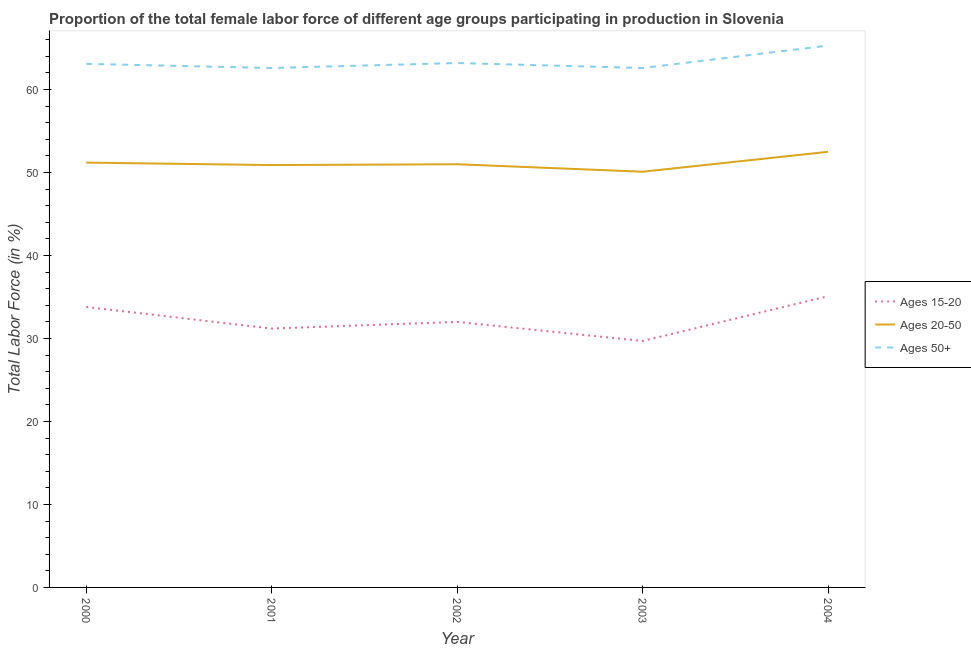What is the percentage of female labor force above age 50 in 2004?
Make the answer very short. 65.3. Across all years, what is the maximum percentage of female labor force above age 50?
Give a very brief answer. 65.3. Across all years, what is the minimum percentage of female labor force above age 50?
Provide a succinct answer. 62.6. In which year was the percentage of female labor force above age 50 minimum?
Your answer should be compact. 2001. What is the total percentage of female labor force within the age group 20-50 in the graph?
Ensure brevity in your answer.  255.7. What is the difference between the percentage of female labor force above age 50 in 2002 and that in 2004?
Your answer should be very brief. -2.1. What is the difference between the percentage of female labor force above age 50 in 2000 and the percentage of female labor force within the age group 20-50 in 2003?
Provide a succinct answer. 13. What is the average percentage of female labor force within the age group 15-20 per year?
Your answer should be compact. 32.36. In the year 2002, what is the difference between the percentage of female labor force above age 50 and percentage of female labor force within the age group 20-50?
Keep it short and to the point. 12.2. What is the ratio of the percentage of female labor force within the age group 20-50 in 2000 to that in 2002?
Give a very brief answer. 1. Is the percentage of female labor force above age 50 in 2000 less than that in 2004?
Offer a terse response. Yes. What is the difference between the highest and the second highest percentage of female labor force within the age group 20-50?
Make the answer very short. 1.3. What is the difference between the highest and the lowest percentage of female labor force within the age group 20-50?
Provide a succinct answer. 2.4. In how many years, is the percentage of female labor force above age 50 greater than the average percentage of female labor force above age 50 taken over all years?
Give a very brief answer. 1. Is the sum of the percentage of female labor force above age 50 in 2002 and 2004 greater than the maximum percentage of female labor force within the age group 15-20 across all years?
Offer a very short reply. Yes. Does the percentage of female labor force within the age group 20-50 monotonically increase over the years?
Keep it short and to the point. No. Is the percentage of female labor force within the age group 15-20 strictly less than the percentage of female labor force within the age group 20-50 over the years?
Keep it short and to the point. Yes. How many years are there in the graph?
Ensure brevity in your answer.  5. Does the graph contain grids?
Offer a terse response. No. Where does the legend appear in the graph?
Your answer should be very brief. Center right. How many legend labels are there?
Keep it short and to the point. 3. How are the legend labels stacked?
Your response must be concise. Vertical. What is the title of the graph?
Your answer should be very brief. Proportion of the total female labor force of different age groups participating in production in Slovenia. Does "Agriculture" appear as one of the legend labels in the graph?
Offer a very short reply. No. What is the label or title of the Y-axis?
Offer a terse response. Total Labor Force (in %). What is the Total Labor Force (in %) of Ages 15-20 in 2000?
Your answer should be very brief. 33.8. What is the Total Labor Force (in %) in Ages 20-50 in 2000?
Provide a short and direct response. 51.2. What is the Total Labor Force (in %) of Ages 50+ in 2000?
Keep it short and to the point. 63.1. What is the Total Labor Force (in %) of Ages 15-20 in 2001?
Keep it short and to the point. 31.2. What is the Total Labor Force (in %) in Ages 20-50 in 2001?
Give a very brief answer. 50.9. What is the Total Labor Force (in %) in Ages 50+ in 2001?
Offer a very short reply. 62.6. What is the Total Labor Force (in %) in Ages 15-20 in 2002?
Your answer should be very brief. 32. What is the Total Labor Force (in %) of Ages 50+ in 2002?
Ensure brevity in your answer.  63.2. What is the Total Labor Force (in %) of Ages 15-20 in 2003?
Provide a short and direct response. 29.7. What is the Total Labor Force (in %) in Ages 20-50 in 2003?
Give a very brief answer. 50.1. What is the Total Labor Force (in %) of Ages 50+ in 2003?
Your answer should be very brief. 62.6. What is the Total Labor Force (in %) of Ages 15-20 in 2004?
Provide a short and direct response. 35.1. What is the Total Labor Force (in %) of Ages 20-50 in 2004?
Keep it short and to the point. 52.5. What is the Total Labor Force (in %) of Ages 50+ in 2004?
Your answer should be compact. 65.3. Across all years, what is the maximum Total Labor Force (in %) in Ages 15-20?
Give a very brief answer. 35.1. Across all years, what is the maximum Total Labor Force (in %) of Ages 20-50?
Offer a terse response. 52.5. Across all years, what is the maximum Total Labor Force (in %) in Ages 50+?
Provide a short and direct response. 65.3. Across all years, what is the minimum Total Labor Force (in %) in Ages 15-20?
Keep it short and to the point. 29.7. Across all years, what is the minimum Total Labor Force (in %) in Ages 20-50?
Give a very brief answer. 50.1. Across all years, what is the minimum Total Labor Force (in %) of Ages 50+?
Offer a terse response. 62.6. What is the total Total Labor Force (in %) in Ages 15-20 in the graph?
Provide a short and direct response. 161.8. What is the total Total Labor Force (in %) of Ages 20-50 in the graph?
Offer a very short reply. 255.7. What is the total Total Labor Force (in %) of Ages 50+ in the graph?
Your answer should be compact. 316.8. What is the difference between the Total Labor Force (in %) in Ages 15-20 in 2000 and that in 2001?
Keep it short and to the point. 2.6. What is the difference between the Total Labor Force (in %) in Ages 20-50 in 2000 and that in 2001?
Offer a terse response. 0.3. What is the difference between the Total Labor Force (in %) of Ages 15-20 in 2000 and that in 2002?
Your answer should be very brief. 1.8. What is the difference between the Total Labor Force (in %) in Ages 50+ in 2000 and that in 2002?
Your answer should be compact. -0.1. What is the difference between the Total Labor Force (in %) in Ages 50+ in 2000 and that in 2003?
Your answer should be very brief. 0.5. What is the difference between the Total Labor Force (in %) in Ages 15-20 in 2000 and that in 2004?
Ensure brevity in your answer.  -1.3. What is the difference between the Total Labor Force (in %) in Ages 20-50 in 2000 and that in 2004?
Provide a short and direct response. -1.3. What is the difference between the Total Labor Force (in %) of Ages 20-50 in 2001 and that in 2002?
Your answer should be very brief. -0.1. What is the difference between the Total Labor Force (in %) of Ages 20-50 in 2001 and that in 2003?
Offer a very short reply. 0.8. What is the difference between the Total Labor Force (in %) of Ages 15-20 in 2001 and that in 2004?
Keep it short and to the point. -3.9. What is the difference between the Total Labor Force (in %) in Ages 50+ in 2001 and that in 2004?
Offer a very short reply. -2.7. What is the difference between the Total Labor Force (in %) in Ages 15-20 in 2002 and that in 2003?
Your answer should be compact. 2.3. What is the difference between the Total Labor Force (in %) in Ages 50+ in 2002 and that in 2003?
Your response must be concise. 0.6. What is the difference between the Total Labor Force (in %) of Ages 20-50 in 2003 and that in 2004?
Ensure brevity in your answer.  -2.4. What is the difference between the Total Labor Force (in %) in Ages 15-20 in 2000 and the Total Labor Force (in %) in Ages 20-50 in 2001?
Your answer should be compact. -17.1. What is the difference between the Total Labor Force (in %) of Ages 15-20 in 2000 and the Total Labor Force (in %) of Ages 50+ in 2001?
Provide a succinct answer. -28.8. What is the difference between the Total Labor Force (in %) in Ages 20-50 in 2000 and the Total Labor Force (in %) in Ages 50+ in 2001?
Make the answer very short. -11.4. What is the difference between the Total Labor Force (in %) of Ages 15-20 in 2000 and the Total Labor Force (in %) of Ages 20-50 in 2002?
Provide a succinct answer. -17.2. What is the difference between the Total Labor Force (in %) in Ages 15-20 in 2000 and the Total Labor Force (in %) in Ages 50+ in 2002?
Your answer should be very brief. -29.4. What is the difference between the Total Labor Force (in %) in Ages 15-20 in 2000 and the Total Labor Force (in %) in Ages 20-50 in 2003?
Keep it short and to the point. -16.3. What is the difference between the Total Labor Force (in %) in Ages 15-20 in 2000 and the Total Labor Force (in %) in Ages 50+ in 2003?
Your answer should be very brief. -28.8. What is the difference between the Total Labor Force (in %) in Ages 15-20 in 2000 and the Total Labor Force (in %) in Ages 20-50 in 2004?
Keep it short and to the point. -18.7. What is the difference between the Total Labor Force (in %) in Ages 15-20 in 2000 and the Total Labor Force (in %) in Ages 50+ in 2004?
Keep it short and to the point. -31.5. What is the difference between the Total Labor Force (in %) in Ages 20-50 in 2000 and the Total Labor Force (in %) in Ages 50+ in 2004?
Your answer should be compact. -14.1. What is the difference between the Total Labor Force (in %) of Ages 15-20 in 2001 and the Total Labor Force (in %) of Ages 20-50 in 2002?
Give a very brief answer. -19.8. What is the difference between the Total Labor Force (in %) of Ages 15-20 in 2001 and the Total Labor Force (in %) of Ages 50+ in 2002?
Your response must be concise. -32. What is the difference between the Total Labor Force (in %) of Ages 20-50 in 2001 and the Total Labor Force (in %) of Ages 50+ in 2002?
Offer a very short reply. -12.3. What is the difference between the Total Labor Force (in %) of Ages 15-20 in 2001 and the Total Labor Force (in %) of Ages 20-50 in 2003?
Provide a succinct answer. -18.9. What is the difference between the Total Labor Force (in %) of Ages 15-20 in 2001 and the Total Labor Force (in %) of Ages 50+ in 2003?
Ensure brevity in your answer.  -31.4. What is the difference between the Total Labor Force (in %) of Ages 15-20 in 2001 and the Total Labor Force (in %) of Ages 20-50 in 2004?
Ensure brevity in your answer.  -21.3. What is the difference between the Total Labor Force (in %) in Ages 15-20 in 2001 and the Total Labor Force (in %) in Ages 50+ in 2004?
Your response must be concise. -34.1. What is the difference between the Total Labor Force (in %) of Ages 20-50 in 2001 and the Total Labor Force (in %) of Ages 50+ in 2004?
Keep it short and to the point. -14.4. What is the difference between the Total Labor Force (in %) of Ages 15-20 in 2002 and the Total Labor Force (in %) of Ages 20-50 in 2003?
Your response must be concise. -18.1. What is the difference between the Total Labor Force (in %) in Ages 15-20 in 2002 and the Total Labor Force (in %) in Ages 50+ in 2003?
Provide a short and direct response. -30.6. What is the difference between the Total Labor Force (in %) of Ages 15-20 in 2002 and the Total Labor Force (in %) of Ages 20-50 in 2004?
Offer a very short reply. -20.5. What is the difference between the Total Labor Force (in %) of Ages 15-20 in 2002 and the Total Labor Force (in %) of Ages 50+ in 2004?
Provide a short and direct response. -33.3. What is the difference between the Total Labor Force (in %) of Ages 20-50 in 2002 and the Total Labor Force (in %) of Ages 50+ in 2004?
Ensure brevity in your answer.  -14.3. What is the difference between the Total Labor Force (in %) in Ages 15-20 in 2003 and the Total Labor Force (in %) in Ages 20-50 in 2004?
Provide a succinct answer. -22.8. What is the difference between the Total Labor Force (in %) in Ages 15-20 in 2003 and the Total Labor Force (in %) in Ages 50+ in 2004?
Your answer should be very brief. -35.6. What is the difference between the Total Labor Force (in %) in Ages 20-50 in 2003 and the Total Labor Force (in %) in Ages 50+ in 2004?
Offer a terse response. -15.2. What is the average Total Labor Force (in %) of Ages 15-20 per year?
Provide a short and direct response. 32.36. What is the average Total Labor Force (in %) of Ages 20-50 per year?
Offer a terse response. 51.14. What is the average Total Labor Force (in %) of Ages 50+ per year?
Ensure brevity in your answer.  63.36. In the year 2000, what is the difference between the Total Labor Force (in %) of Ages 15-20 and Total Labor Force (in %) of Ages 20-50?
Provide a short and direct response. -17.4. In the year 2000, what is the difference between the Total Labor Force (in %) of Ages 15-20 and Total Labor Force (in %) of Ages 50+?
Your answer should be very brief. -29.3. In the year 2001, what is the difference between the Total Labor Force (in %) in Ages 15-20 and Total Labor Force (in %) in Ages 20-50?
Provide a succinct answer. -19.7. In the year 2001, what is the difference between the Total Labor Force (in %) in Ages 15-20 and Total Labor Force (in %) in Ages 50+?
Keep it short and to the point. -31.4. In the year 2001, what is the difference between the Total Labor Force (in %) of Ages 20-50 and Total Labor Force (in %) of Ages 50+?
Provide a succinct answer. -11.7. In the year 2002, what is the difference between the Total Labor Force (in %) of Ages 15-20 and Total Labor Force (in %) of Ages 50+?
Provide a succinct answer. -31.2. In the year 2002, what is the difference between the Total Labor Force (in %) in Ages 20-50 and Total Labor Force (in %) in Ages 50+?
Make the answer very short. -12.2. In the year 2003, what is the difference between the Total Labor Force (in %) in Ages 15-20 and Total Labor Force (in %) in Ages 20-50?
Your answer should be very brief. -20.4. In the year 2003, what is the difference between the Total Labor Force (in %) in Ages 15-20 and Total Labor Force (in %) in Ages 50+?
Ensure brevity in your answer.  -32.9. In the year 2004, what is the difference between the Total Labor Force (in %) in Ages 15-20 and Total Labor Force (in %) in Ages 20-50?
Make the answer very short. -17.4. In the year 2004, what is the difference between the Total Labor Force (in %) of Ages 15-20 and Total Labor Force (in %) of Ages 50+?
Make the answer very short. -30.2. In the year 2004, what is the difference between the Total Labor Force (in %) in Ages 20-50 and Total Labor Force (in %) in Ages 50+?
Your answer should be very brief. -12.8. What is the ratio of the Total Labor Force (in %) of Ages 15-20 in 2000 to that in 2001?
Your answer should be compact. 1.08. What is the ratio of the Total Labor Force (in %) of Ages 20-50 in 2000 to that in 2001?
Provide a succinct answer. 1.01. What is the ratio of the Total Labor Force (in %) of Ages 50+ in 2000 to that in 2001?
Keep it short and to the point. 1.01. What is the ratio of the Total Labor Force (in %) in Ages 15-20 in 2000 to that in 2002?
Give a very brief answer. 1.06. What is the ratio of the Total Labor Force (in %) in Ages 50+ in 2000 to that in 2002?
Make the answer very short. 1. What is the ratio of the Total Labor Force (in %) in Ages 15-20 in 2000 to that in 2003?
Offer a very short reply. 1.14. What is the ratio of the Total Labor Force (in %) of Ages 20-50 in 2000 to that in 2003?
Your response must be concise. 1.02. What is the ratio of the Total Labor Force (in %) of Ages 50+ in 2000 to that in 2003?
Your answer should be very brief. 1.01. What is the ratio of the Total Labor Force (in %) of Ages 15-20 in 2000 to that in 2004?
Your answer should be compact. 0.96. What is the ratio of the Total Labor Force (in %) in Ages 20-50 in 2000 to that in 2004?
Ensure brevity in your answer.  0.98. What is the ratio of the Total Labor Force (in %) of Ages 50+ in 2000 to that in 2004?
Ensure brevity in your answer.  0.97. What is the ratio of the Total Labor Force (in %) in Ages 20-50 in 2001 to that in 2002?
Give a very brief answer. 1. What is the ratio of the Total Labor Force (in %) in Ages 50+ in 2001 to that in 2002?
Provide a short and direct response. 0.99. What is the ratio of the Total Labor Force (in %) of Ages 15-20 in 2001 to that in 2003?
Offer a terse response. 1.05. What is the ratio of the Total Labor Force (in %) of Ages 20-50 in 2001 to that in 2003?
Your response must be concise. 1.02. What is the ratio of the Total Labor Force (in %) in Ages 20-50 in 2001 to that in 2004?
Offer a very short reply. 0.97. What is the ratio of the Total Labor Force (in %) of Ages 50+ in 2001 to that in 2004?
Your answer should be very brief. 0.96. What is the ratio of the Total Labor Force (in %) of Ages 15-20 in 2002 to that in 2003?
Offer a terse response. 1.08. What is the ratio of the Total Labor Force (in %) in Ages 50+ in 2002 to that in 2003?
Give a very brief answer. 1.01. What is the ratio of the Total Labor Force (in %) in Ages 15-20 in 2002 to that in 2004?
Keep it short and to the point. 0.91. What is the ratio of the Total Labor Force (in %) of Ages 20-50 in 2002 to that in 2004?
Ensure brevity in your answer.  0.97. What is the ratio of the Total Labor Force (in %) in Ages 50+ in 2002 to that in 2004?
Ensure brevity in your answer.  0.97. What is the ratio of the Total Labor Force (in %) of Ages 15-20 in 2003 to that in 2004?
Keep it short and to the point. 0.85. What is the ratio of the Total Labor Force (in %) in Ages 20-50 in 2003 to that in 2004?
Offer a very short reply. 0.95. What is the ratio of the Total Labor Force (in %) of Ages 50+ in 2003 to that in 2004?
Provide a succinct answer. 0.96. What is the difference between the highest and the second highest Total Labor Force (in %) in Ages 50+?
Your answer should be very brief. 2.1. What is the difference between the highest and the lowest Total Labor Force (in %) of Ages 15-20?
Your response must be concise. 5.4. What is the difference between the highest and the lowest Total Labor Force (in %) of Ages 50+?
Your response must be concise. 2.7. 